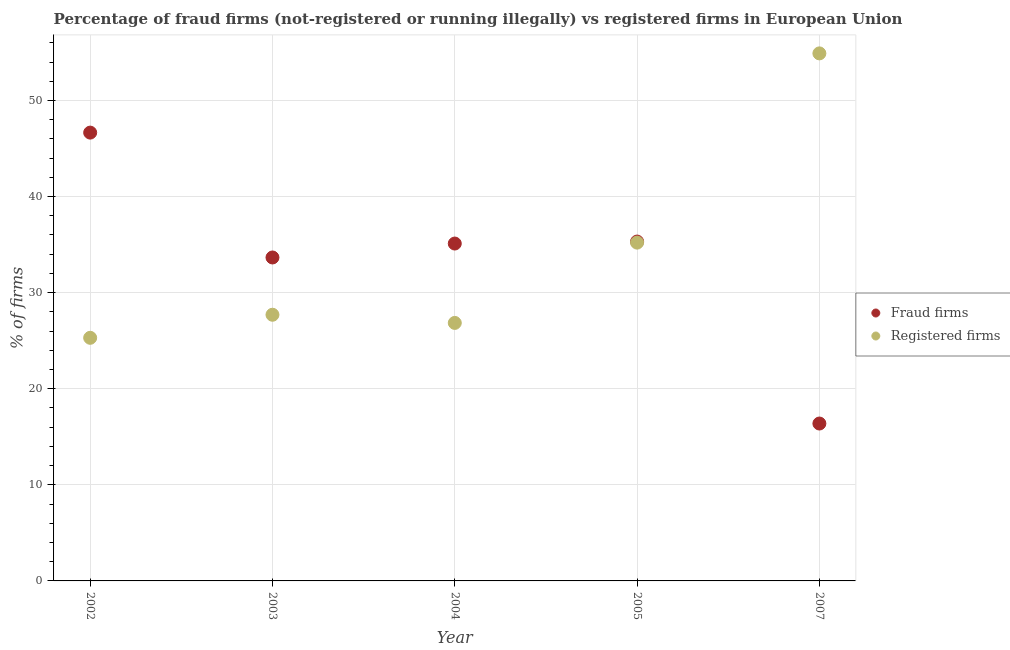What is the percentage of registered firms in 2005?
Keep it short and to the point. 35.21. Across all years, what is the maximum percentage of fraud firms?
Offer a terse response. 46.65. Across all years, what is the minimum percentage of fraud firms?
Your answer should be very brief. 16.38. In which year was the percentage of registered firms maximum?
Your answer should be very brief. 2007. In which year was the percentage of registered firms minimum?
Offer a very short reply. 2002. What is the total percentage of fraud firms in the graph?
Offer a terse response. 167.12. What is the difference between the percentage of registered firms in 2003 and that in 2004?
Offer a terse response. 0.85. What is the difference between the percentage of fraud firms in 2003 and the percentage of registered firms in 2007?
Your response must be concise. -21.24. What is the average percentage of registered firms per year?
Keep it short and to the point. 33.99. In the year 2005, what is the difference between the percentage of fraud firms and percentage of registered firms?
Give a very brief answer. 0.11. What is the ratio of the percentage of fraud firms in 2004 to that in 2007?
Your response must be concise. 2.14. Is the percentage of registered firms in 2003 less than that in 2007?
Offer a terse response. Yes. Is the difference between the percentage of registered firms in 2004 and 2005 greater than the difference between the percentage of fraud firms in 2004 and 2005?
Ensure brevity in your answer.  No. What is the difference between the highest and the second highest percentage of fraud firms?
Give a very brief answer. 11.34. What is the difference between the highest and the lowest percentage of fraud firms?
Offer a terse response. 30.27. Is the sum of the percentage of registered firms in 2002 and 2005 greater than the maximum percentage of fraud firms across all years?
Provide a short and direct response. Yes. How many dotlines are there?
Provide a succinct answer. 2. What is the difference between two consecutive major ticks on the Y-axis?
Keep it short and to the point. 10. Does the graph contain any zero values?
Keep it short and to the point. No. Where does the legend appear in the graph?
Give a very brief answer. Center right. How are the legend labels stacked?
Give a very brief answer. Vertical. What is the title of the graph?
Offer a very short reply. Percentage of fraud firms (not-registered or running illegally) vs registered firms in European Union. What is the label or title of the Y-axis?
Keep it short and to the point. % of firms. What is the % of firms in Fraud firms in 2002?
Offer a very short reply. 46.65. What is the % of firms of Registered firms in 2002?
Ensure brevity in your answer.  25.3. What is the % of firms of Fraud firms in 2003?
Give a very brief answer. 33.66. What is the % of firms of Registered firms in 2003?
Your response must be concise. 27.7. What is the % of firms of Fraud firms in 2004?
Provide a short and direct response. 35.11. What is the % of firms in Registered firms in 2004?
Provide a succinct answer. 26.85. What is the % of firms of Fraud firms in 2005?
Your answer should be compact. 35.32. What is the % of firms in Registered firms in 2005?
Your answer should be very brief. 35.21. What is the % of firms in Fraud firms in 2007?
Provide a short and direct response. 16.38. What is the % of firms in Registered firms in 2007?
Give a very brief answer. 54.9. Across all years, what is the maximum % of firms in Fraud firms?
Offer a terse response. 46.65. Across all years, what is the maximum % of firms in Registered firms?
Provide a succinct answer. 54.9. Across all years, what is the minimum % of firms of Fraud firms?
Give a very brief answer. 16.38. Across all years, what is the minimum % of firms in Registered firms?
Provide a short and direct response. 25.3. What is the total % of firms in Fraud firms in the graph?
Ensure brevity in your answer.  167.12. What is the total % of firms of Registered firms in the graph?
Your answer should be compact. 169.96. What is the difference between the % of firms of Fraud firms in 2002 and that in 2003?
Offer a terse response. 12.99. What is the difference between the % of firms of Fraud firms in 2002 and that in 2004?
Make the answer very short. 11.54. What is the difference between the % of firms in Registered firms in 2002 and that in 2004?
Offer a very short reply. -1.55. What is the difference between the % of firms in Fraud firms in 2002 and that in 2005?
Ensure brevity in your answer.  11.34. What is the difference between the % of firms in Registered firms in 2002 and that in 2005?
Provide a succinct answer. -9.91. What is the difference between the % of firms in Fraud firms in 2002 and that in 2007?
Keep it short and to the point. 30.27. What is the difference between the % of firms of Registered firms in 2002 and that in 2007?
Keep it short and to the point. -29.6. What is the difference between the % of firms in Fraud firms in 2003 and that in 2004?
Give a very brief answer. -1.45. What is the difference between the % of firms of Registered firms in 2003 and that in 2004?
Provide a short and direct response. 0.85. What is the difference between the % of firms of Fraud firms in 2003 and that in 2005?
Make the answer very short. -1.66. What is the difference between the % of firms in Registered firms in 2003 and that in 2005?
Give a very brief answer. -7.51. What is the difference between the % of firms in Fraud firms in 2003 and that in 2007?
Give a very brief answer. 17.28. What is the difference between the % of firms in Registered firms in 2003 and that in 2007?
Give a very brief answer. -27.2. What is the difference between the % of firms in Fraud firms in 2004 and that in 2005?
Your response must be concise. -0.21. What is the difference between the % of firms in Registered firms in 2004 and that in 2005?
Make the answer very short. -8.36. What is the difference between the % of firms in Fraud firms in 2004 and that in 2007?
Give a very brief answer. 18.73. What is the difference between the % of firms in Registered firms in 2004 and that in 2007?
Your response must be concise. -28.05. What is the difference between the % of firms of Fraud firms in 2005 and that in 2007?
Offer a very short reply. 18.94. What is the difference between the % of firms in Registered firms in 2005 and that in 2007?
Ensure brevity in your answer.  -19.69. What is the difference between the % of firms of Fraud firms in 2002 and the % of firms of Registered firms in 2003?
Offer a very short reply. 18.95. What is the difference between the % of firms in Fraud firms in 2002 and the % of firms in Registered firms in 2004?
Give a very brief answer. 19.8. What is the difference between the % of firms of Fraud firms in 2002 and the % of firms of Registered firms in 2005?
Make the answer very short. 11.45. What is the difference between the % of firms of Fraud firms in 2002 and the % of firms of Registered firms in 2007?
Your response must be concise. -8.25. What is the difference between the % of firms in Fraud firms in 2003 and the % of firms in Registered firms in 2004?
Give a very brief answer. 6.81. What is the difference between the % of firms in Fraud firms in 2003 and the % of firms in Registered firms in 2005?
Your response must be concise. -1.55. What is the difference between the % of firms in Fraud firms in 2003 and the % of firms in Registered firms in 2007?
Your answer should be compact. -21.24. What is the difference between the % of firms of Fraud firms in 2004 and the % of firms of Registered firms in 2005?
Your answer should be very brief. -0.1. What is the difference between the % of firms in Fraud firms in 2004 and the % of firms in Registered firms in 2007?
Offer a very short reply. -19.79. What is the difference between the % of firms in Fraud firms in 2005 and the % of firms in Registered firms in 2007?
Make the answer very short. -19.58. What is the average % of firms of Fraud firms per year?
Offer a very short reply. 33.42. What is the average % of firms of Registered firms per year?
Keep it short and to the point. 33.99. In the year 2002, what is the difference between the % of firms in Fraud firms and % of firms in Registered firms?
Offer a terse response. 21.35. In the year 2003, what is the difference between the % of firms in Fraud firms and % of firms in Registered firms?
Offer a terse response. 5.96. In the year 2004, what is the difference between the % of firms of Fraud firms and % of firms of Registered firms?
Your answer should be compact. 8.26. In the year 2005, what is the difference between the % of firms in Fraud firms and % of firms in Registered firms?
Your answer should be very brief. 0.11. In the year 2007, what is the difference between the % of firms in Fraud firms and % of firms in Registered firms?
Offer a very short reply. -38.52. What is the ratio of the % of firms of Fraud firms in 2002 to that in 2003?
Make the answer very short. 1.39. What is the ratio of the % of firms of Registered firms in 2002 to that in 2003?
Provide a succinct answer. 0.91. What is the ratio of the % of firms of Fraud firms in 2002 to that in 2004?
Provide a succinct answer. 1.33. What is the ratio of the % of firms of Registered firms in 2002 to that in 2004?
Offer a terse response. 0.94. What is the ratio of the % of firms of Fraud firms in 2002 to that in 2005?
Offer a terse response. 1.32. What is the ratio of the % of firms of Registered firms in 2002 to that in 2005?
Your answer should be very brief. 0.72. What is the ratio of the % of firms in Fraud firms in 2002 to that in 2007?
Ensure brevity in your answer.  2.85. What is the ratio of the % of firms in Registered firms in 2002 to that in 2007?
Make the answer very short. 0.46. What is the ratio of the % of firms of Fraud firms in 2003 to that in 2004?
Ensure brevity in your answer.  0.96. What is the ratio of the % of firms in Registered firms in 2003 to that in 2004?
Make the answer very short. 1.03. What is the ratio of the % of firms in Fraud firms in 2003 to that in 2005?
Offer a terse response. 0.95. What is the ratio of the % of firms in Registered firms in 2003 to that in 2005?
Offer a terse response. 0.79. What is the ratio of the % of firms of Fraud firms in 2003 to that in 2007?
Keep it short and to the point. 2.05. What is the ratio of the % of firms of Registered firms in 2003 to that in 2007?
Provide a short and direct response. 0.5. What is the ratio of the % of firms in Registered firms in 2004 to that in 2005?
Provide a succinct answer. 0.76. What is the ratio of the % of firms in Fraud firms in 2004 to that in 2007?
Your answer should be very brief. 2.14. What is the ratio of the % of firms of Registered firms in 2004 to that in 2007?
Give a very brief answer. 0.49. What is the ratio of the % of firms in Fraud firms in 2005 to that in 2007?
Give a very brief answer. 2.16. What is the ratio of the % of firms in Registered firms in 2005 to that in 2007?
Your answer should be compact. 0.64. What is the difference between the highest and the second highest % of firms in Fraud firms?
Your answer should be compact. 11.34. What is the difference between the highest and the second highest % of firms of Registered firms?
Give a very brief answer. 19.69. What is the difference between the highest and the lowest % of firms in Fraud firms?
Offer a terse response. 30.27. What is the difference between the highest and the lowest % of firms of Registered firms?
Make the answer very short. 29.6. 